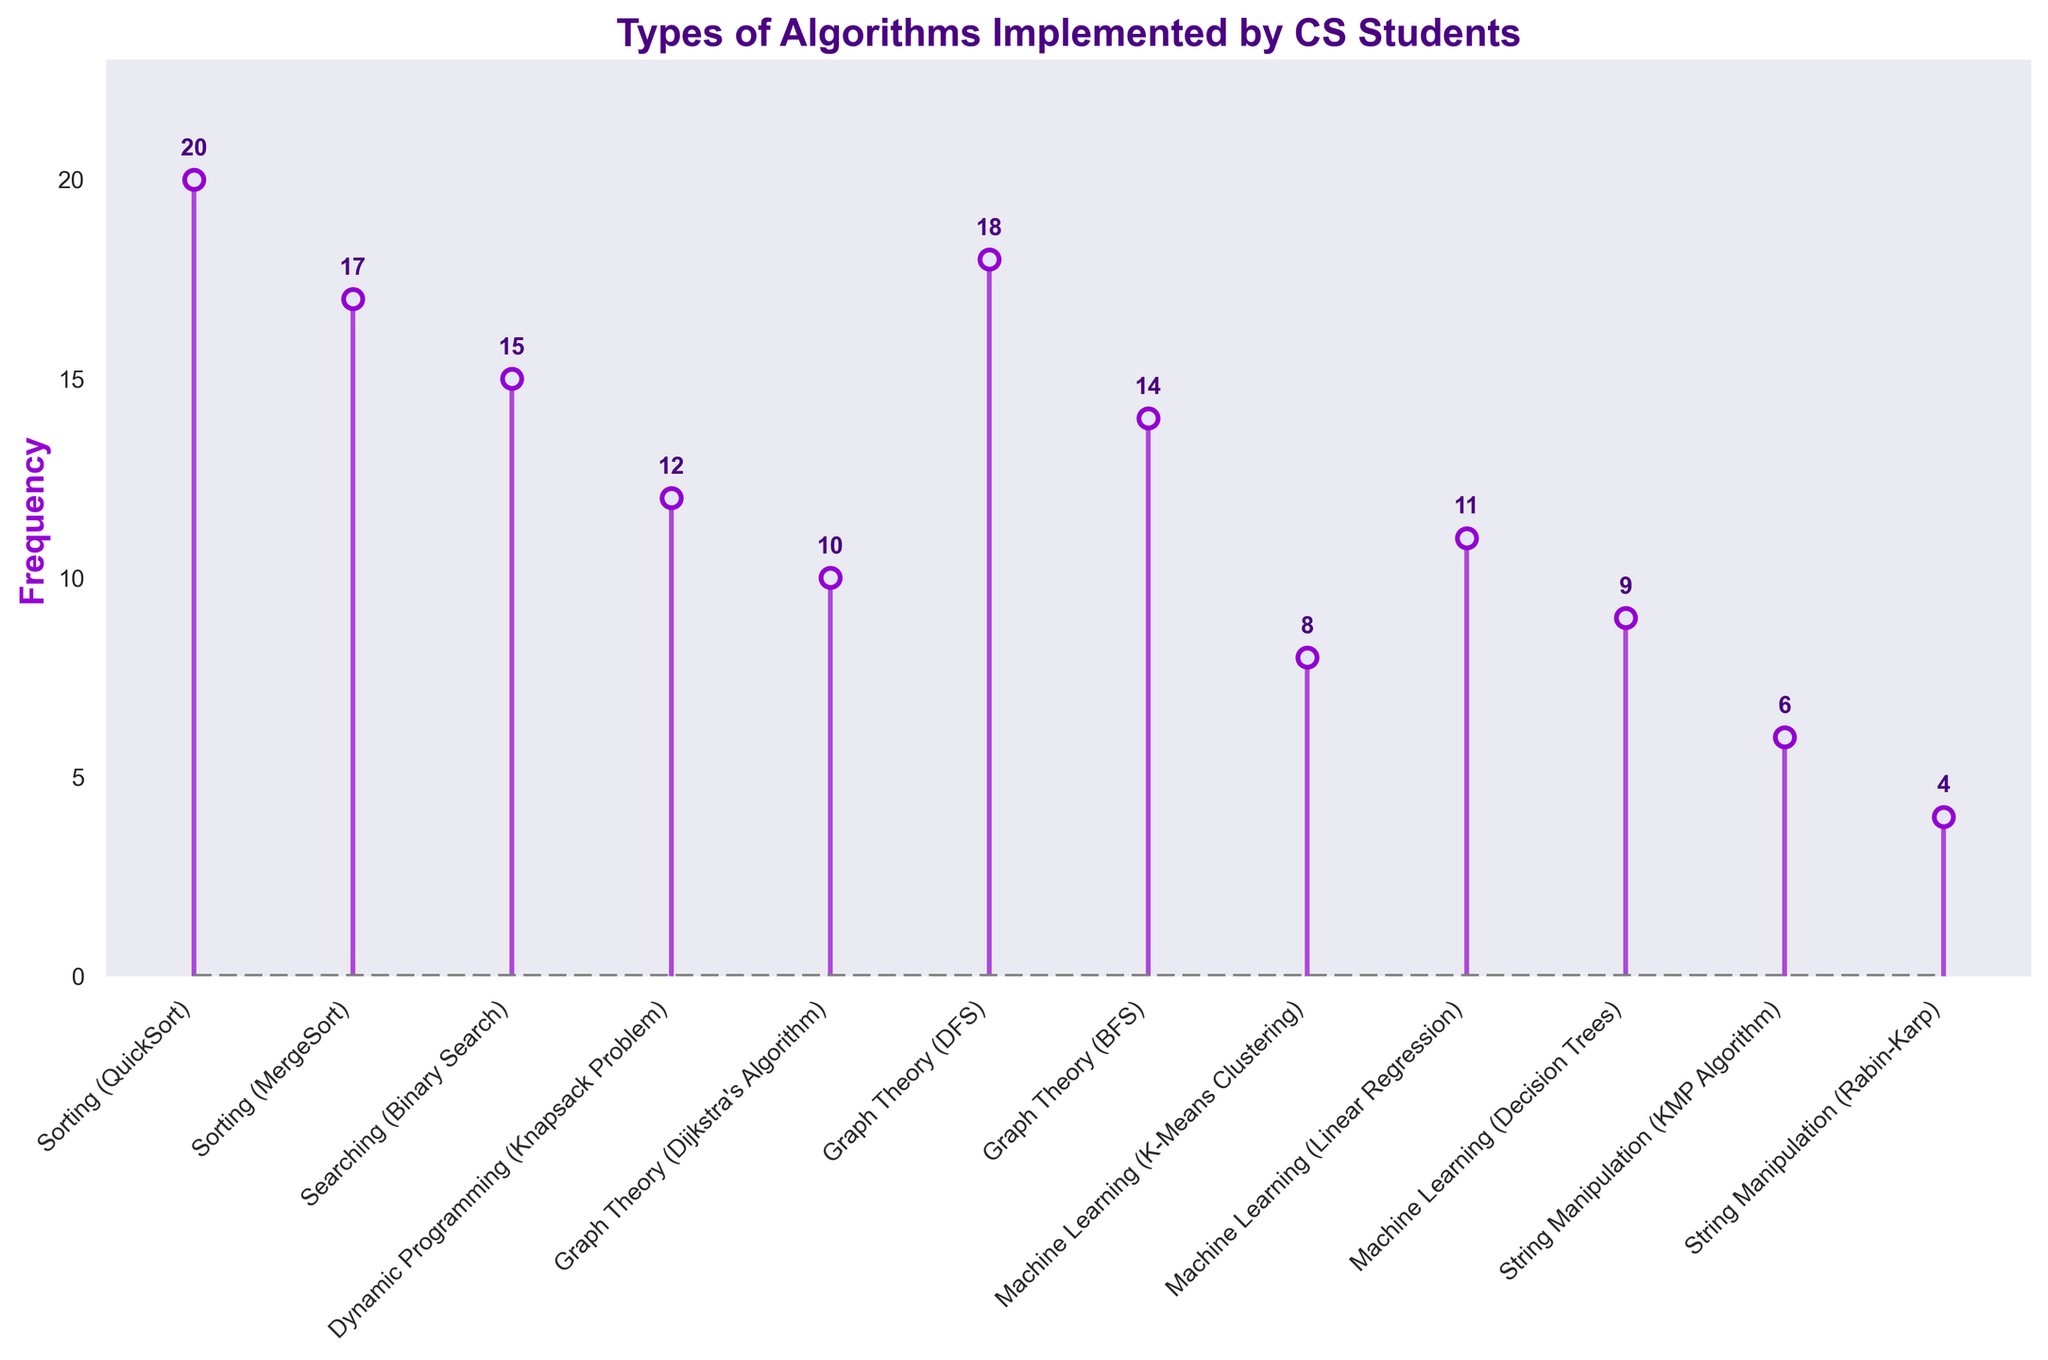What is the title of the figure? The title of the figure can be found at the top center of the plot. It reads "Types of Algorithms Implemented by CS Students".
Answer: Types of Algorithms Implemented by CS Students How many algorithms have a frequency greater than 15? By counting the bars with frequencies greater than 15, we see that "Sorting (QuickSort)", "Sorting (MergeSort)", "Graph Theory (DFS)", and "Searching (Binary Search)" have frequencies greater than 15.
Answer: 4 Which algorithm has the lowest frequency? By looking at the lowest bar on the chart, "String Manipulation (Rabin-Karp)" is the algorithm with the lowest frequency.
Answer: String Manipulation (Rabin-Karp) What is the combined frequency of "Machine Learning (K-Means Clustering)" and "Machine Learning (Decision Trees)"? Add the frequencies of "Machine Learning (K-Means Clustering)" and "Machine Learning (Decision Trees)". The combined frequency is 8 + 9 = 17.
Answer: 17 What is the frequency difference between "Graph Theory (BFS)" and "Graph Theory (Dijkstra's Algorithm)"? Subtract the frequency of "Graph Theory (Dijkstra's Algorithm)" from "Graph Theory (BFS)". The difference is 14 - 10 = 4.
Answer: 4 Which algorithm in the "String Manipulation" category has a higher frequency? Comparing the frequencies of "String Manipulation (KMP Algorithm)" and "String Manipulation (Rabin-Karp)", the "KMP Algorithm" has a higher frequency.
Answer: String Manipulation (KMP Algorithm) Are there more sorting algorithms or machine learning algorithms? Counting the sorting algorithms ("QuickSort" and "MergeSort") and the machine learning algorithms ("K-Means Clustering", "Linear Regression", and "Decision Trees"), there are more machine learning algorithms.
Answer: Machine Learning Algorithms What is the median frequency of all algorithms? To find the median, list the frequencies in order: 4, 6, 8, 9, 10, 11, 12, 14, 15, 17, 18, 20. The median is the average of the 6th and 7th values: (11+12)/2 = 11.5.
Answer: 11.5 What is the average frequency of the listed algorithms? Add all the frequencies together and divide by the number of algorithms. The sum is 146, and there are 12 algorithms. 146/12 = 12.17.
Answer: 12.17 How many graph theory algorithms are listed, and what is their total frequency? There are three graph theory algorithms ("Dijkstra's Algorithm", "DFS", and "BFS"). Their total frequency is 10 + 18 + 14 = 42.
Answer: 3 algorithms, total frequency 42 